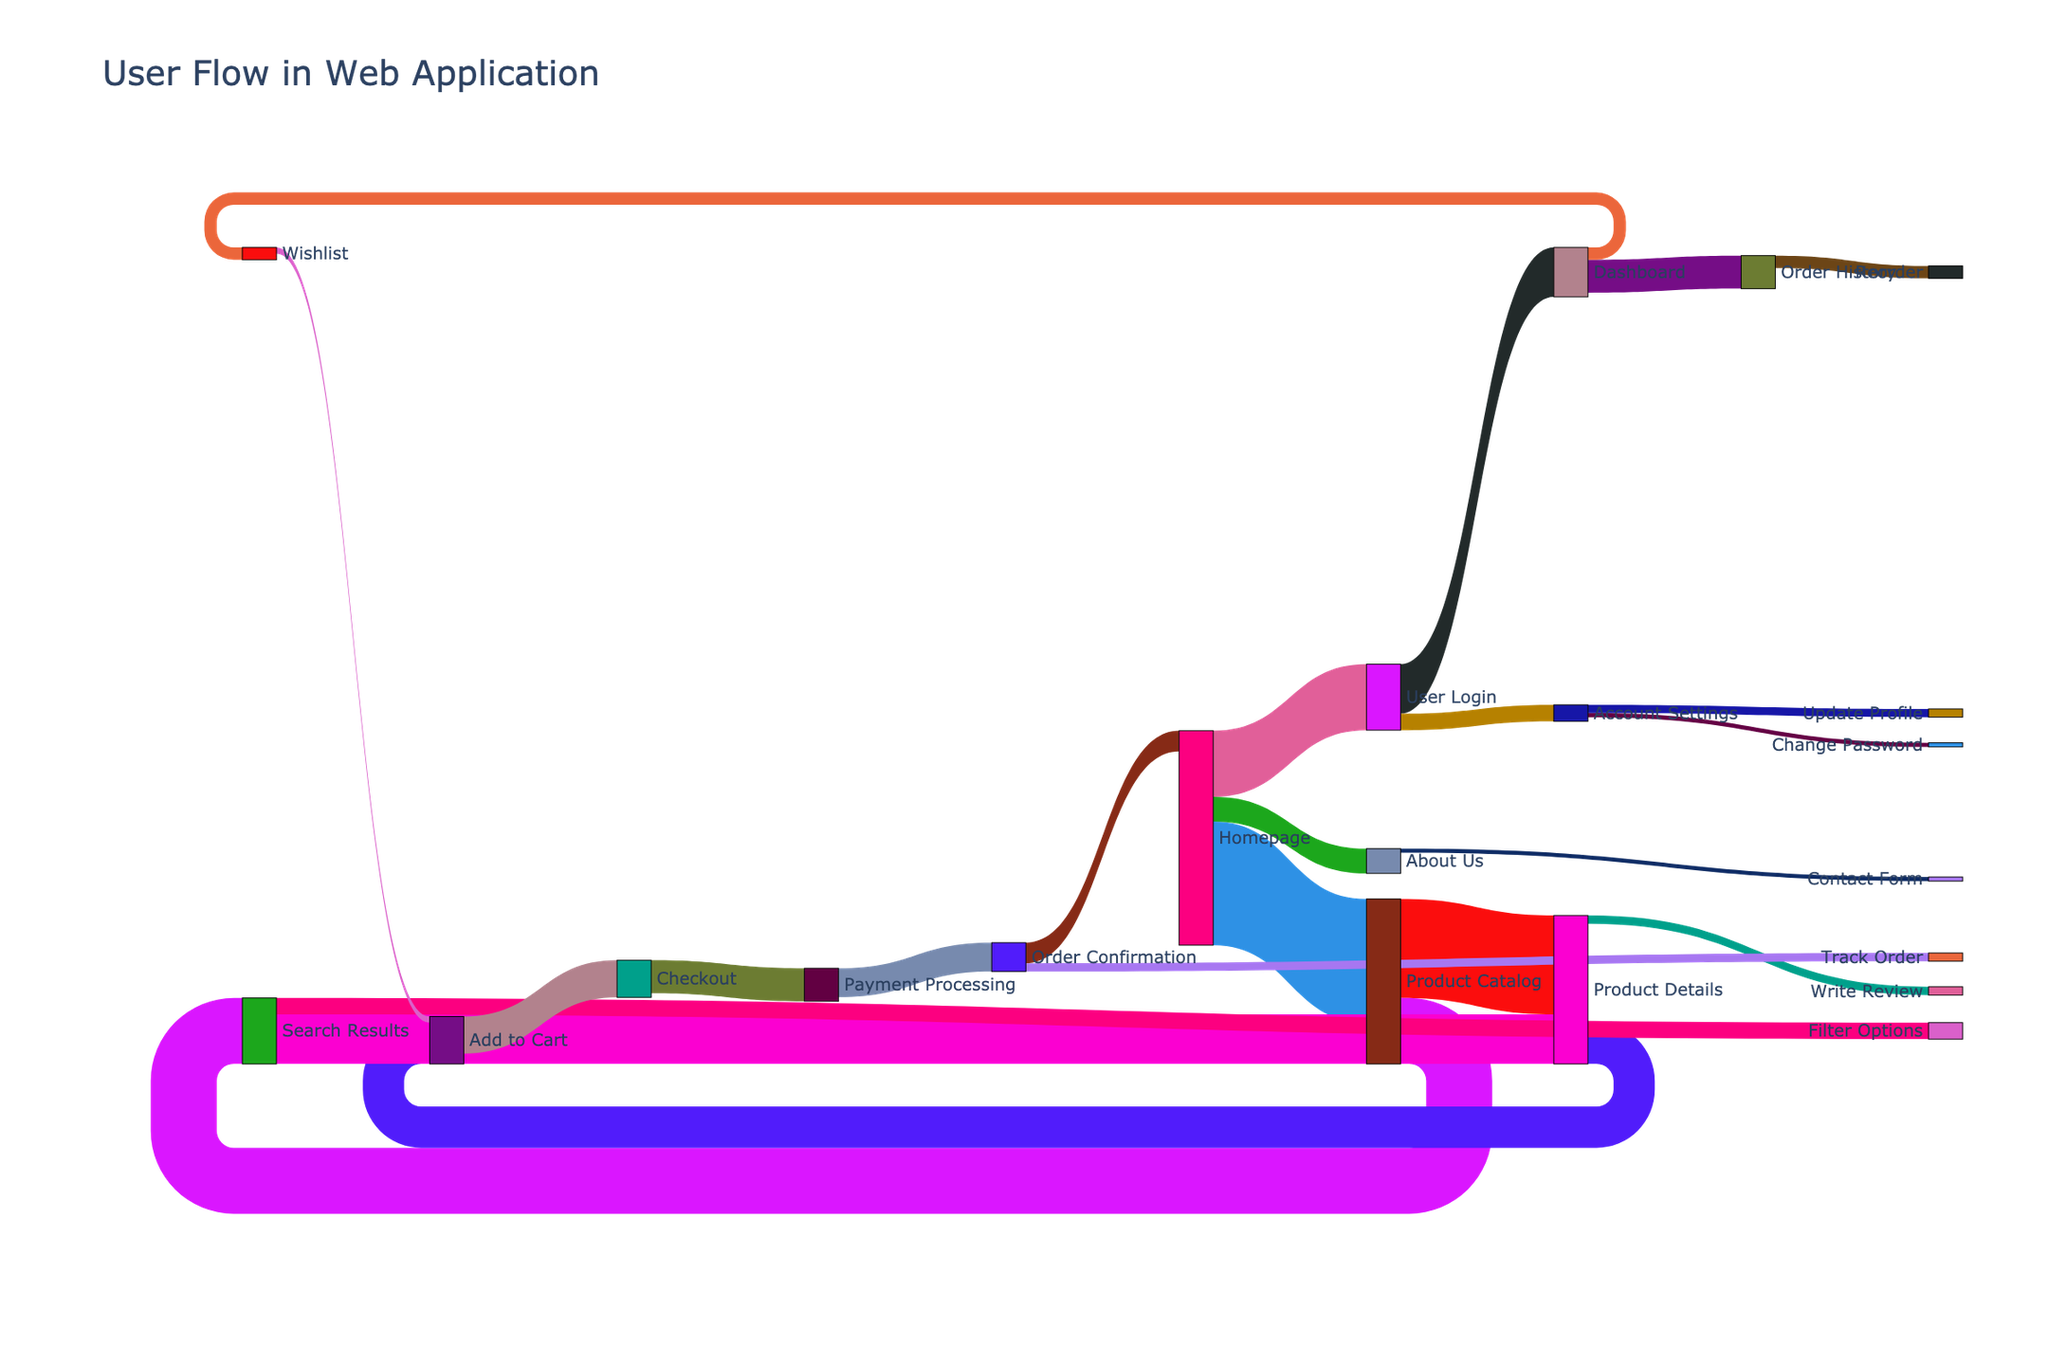what's the main title of the figure? The main title of the figure can be found at the very top of the plot and is typically displayed in a larger font size compared to other text elements.
Answer: User Flow in Web Application what is the most frequent interaction starting from the 'Homepage'? Look for the link originating from 'Homepage' with the highest value. The thickness of the link correlates with its value.
Answer: Product Catalog which path has the highest value overall? Identify the link with the largest value regardless of its source or target. Check the values associated with each link.
Answer: Product Catalog to Product Details what is the total user flow to 'Product Details'? Sum the values of all incoming links to the 'Product Details' node. Specifically, these are from 'Product Catalog' and 'Search Results'.
Answer: 1800 how does the user flow from 'Product Catalog' compare to 'User Login'? Compare the outgoing flows from both nodes by summing their respective values. 'Product Catalog' has flows to 'Product Details' and 'Search Results'. 'User Login' has flows to 'Dashboard' and 'Account Settings'.
Answer: Product Catalog > User Login what proportion of users who start at 'Homepage' end up at 'Payment Processing'? First calculate the total flow from 'Homepage', then trace the paths leading to 'Payment Processing' and calculate the proportion.
Answer: 16% how many users navigate from 'Dashboard' to 'Order History' compared to those who go to 'Wishlist'? Check the values of the links from 'Dashboard' to 'Order History' and 'Wishlist', then compare these values.
Answer: Order History > Wishlist what are the potential endpoints for users starting from 'User Login'? Trace the paths starting from 'User Login' and list all final nodes in those paths, considering possible intermediate steps.
Answer: Order History, Wishlist, Change Password, Update Profile what is the least frequent subsequent action after 'Product Details'? Identify all outgoing links from 'Product Details' and compare their values to determine the smallest one.
Answer: Write Review where do users go after 'Order Confirmation'? Check the target nodes associated with the outgoing links from 'Order Confirmation'.
Answer: Homepage, Track Order 